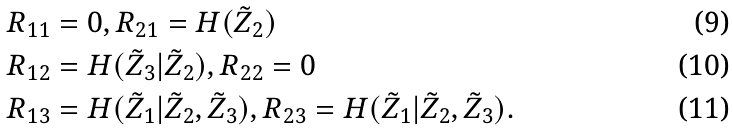<formula> <loc_0><loc_0><loc_500><loc_500>R _ { 1 1 } & = 0 , R _ { 2 1 } = H ( \tilde { Z } _ { 2 } ) \\ R _ { 1 2 } & = H ( \tilde { Z } _ { 3 } | \tilde { Z } _ { 2 } ) , R _ { 2 2 } = 0 \\ R _ { 1 3 } & = H ( \tilde { Z } _ { 1 } | \tilde { Z } _ { 2 } , \tilde { Z } _ { 3 } ) , R _ { 2 3 } = H ( \tilde { Z } _ { 1 } | \tilde { Z } _ { 2 } , \tilde { Z } _ { 3 } ) .</formula> 